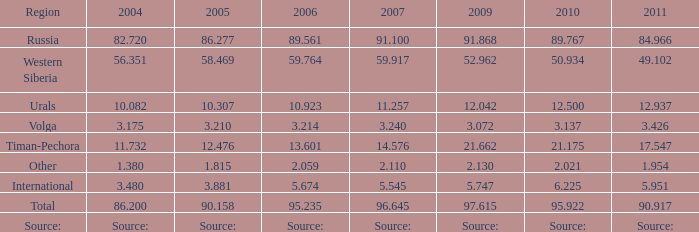What is the 2005 Lukoil oil prodroduction when in 2007 oil production 5.545 million tonnes? 3.881. 